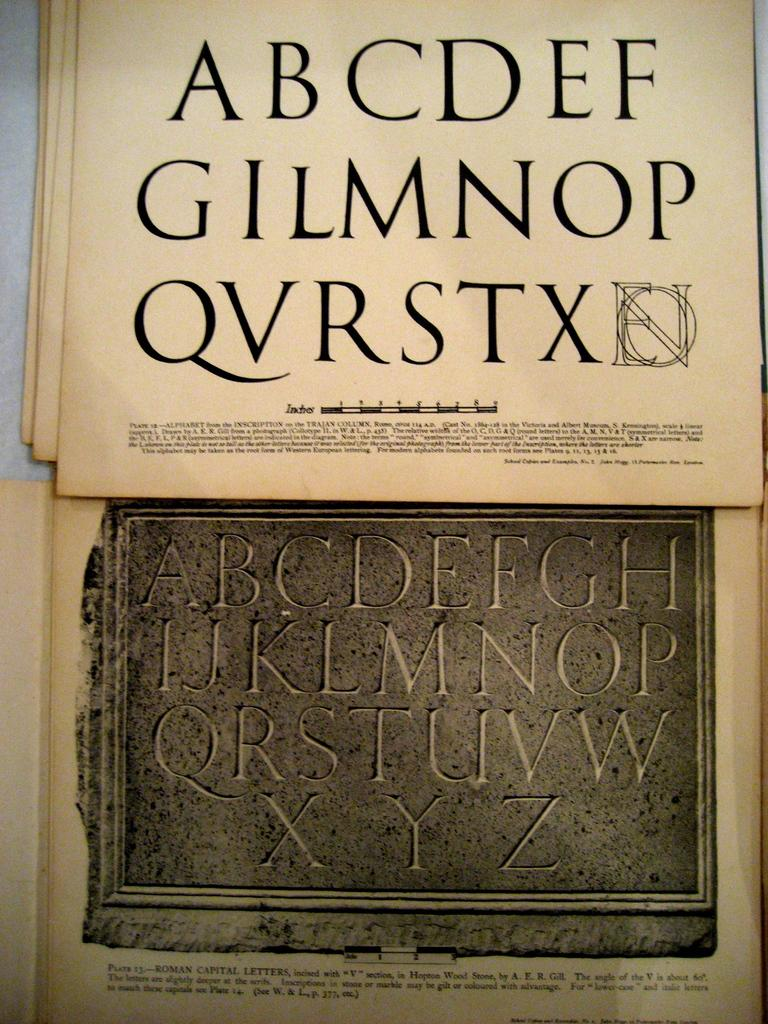<image>
Give a short and clear explanation of the subsequent image. Written text that shows an older English alphabet, missing 'H', 'J', 'K', 'U', 'Y', and 'Z' with 'V' not in the modern order, over a picture with a modern alphabet. 